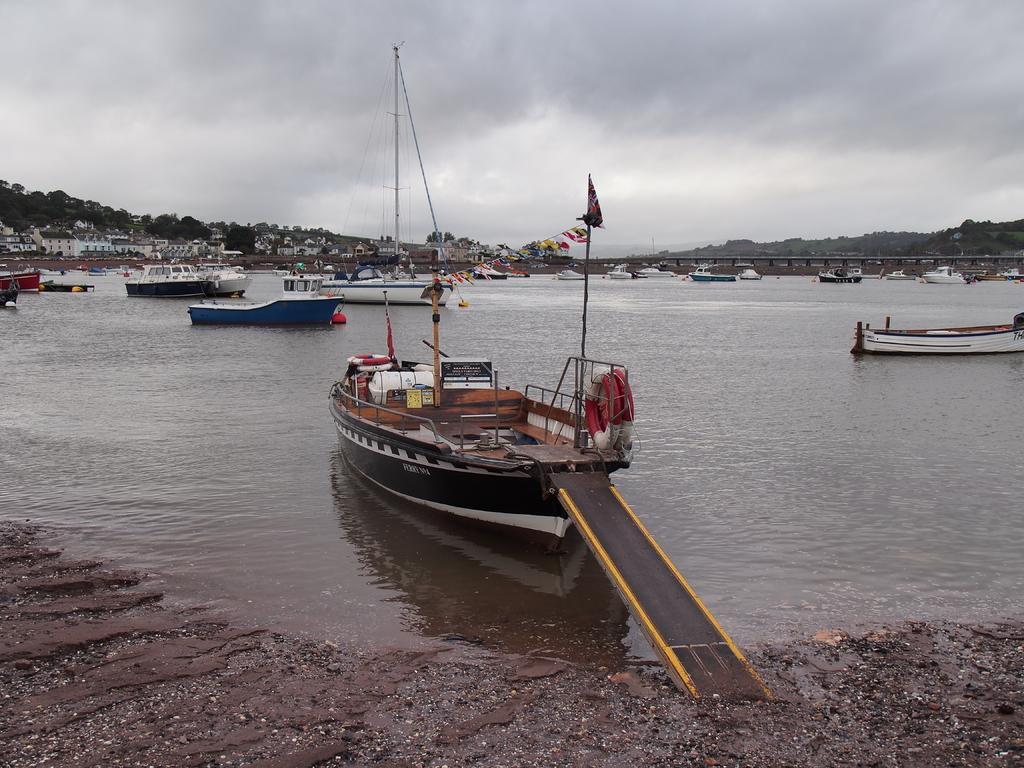Describe this image in one or two sentences. These are the boats, which are on the water. I can see the trees and buildings in the background. This looks like a bridge. These are the clouds in the sky. 